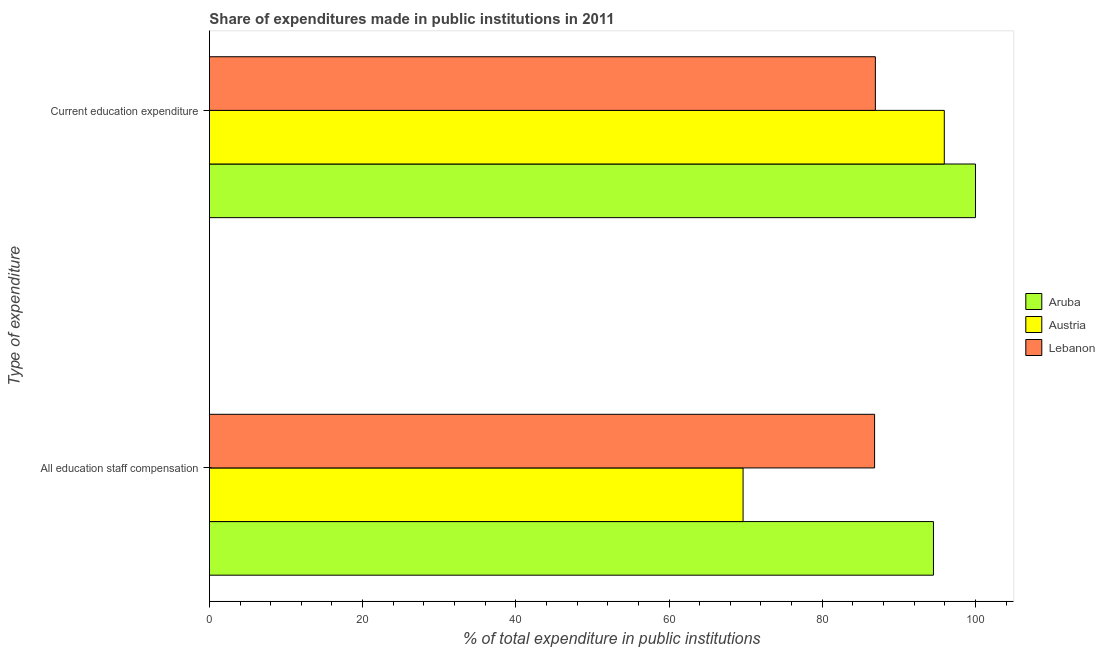How many groups of bars are there?
Provide a succinct answer. 2. Are the number of bars on each tick of the Y-axis equal?
Your answer should be very brief. Yes. How many bars are there on the 1st tick from the bottom?
Offer a terse response. 3. What is the label of the 1st group of bars from the top?
Offer a terse response. Current education expenditure. What is the expenditure in staff compensation in Austria?
Your answer should be very brief. 69.66. Across all countries, what is the maximum expenditure in staff compensation?
Your answer should be compact. 94.51. Across all countries, what is the minimum expenditure in staff compensation?
Offer a very short reply. 69.66. In which country was the expenditure in staff compensation maximum?
Your answer should be very brief. Aruba. In which country was the expenditure in staff compensation minimum?
Give a very brief answer. Austria. What is the total expenditure in education in the graph?
Ensure brevity in your answer.  282.86. What is the difference between the expenditure in staff compensation in Aruba and that in Austria?
Your answer should be very brief. 24.85. What is the difference between the expenditure in staff compensation in Aruba and the expenditure in education in Lebanon?
Keep it short and to the point. 7.58. What is the average expenditure in staff compensation per country?
Make the answer very short. 83.67. What is the difference between the expenditure in education and expenditure in staff compensation in Aruba?
Offer a very short reply. 5.49. What is the ratio of the expenditure in education in Lebanon to that in Aruba?
Ensure brevity in your answer.  0.87. Is the expenditure in staff compensation in Lebanon less than that in Aruba?
Provide a succinct answer. Yes. In how many countries, is the expenditure in education greater than the average expenditure in education taken over all countries?
Your answer should be very brief. 2. What does the 3rd bar from the top in All education staff compensation represents?
Offer a terse response. Aruba. Are all the bars in the graph horizontal?
Give a very brief answer. Yes. Are the values on the major ticks of X-axis written in scientific E-notation?
Give a very brief answer. No. Does the graph contain any zero values?
Offer a very short reply. No. Does the graph contain grids?
Your response must be concise. No. Where does the legend appear in the graph?
Your answer should be compact. Center right. How many legend labels are there?
Keep it short and to the point. 3. How are the legend labels stacked?
Your answer should be very brief. Vertical. What is the title of the graph?
Provide a short and direct response. Share of expenditures made in public institutions in 2011. What is the label or title of the X-axis?
Make the answer very short. % of total expenditure in public institutions. What is the label or title of the Y-axis?
Offer a very short reply. Type of expenditure. What is the % of total expenditure in public institutions in Aruba in All education staff compensation?
Keep it short and to the point. 94.51. What is the % of total expenditure in public institutions in Austria in All education staff compensation?
Provide a short and direct response. 69.66. What is the % of total expenditure in public institutions of Lebanon in All education staff compensation?
Ensure brevity in your answer.  86.83. What is the % of total expenditure in public institutions of Austria in Current education expenditure?
Make the answer very short. 95.93. What is the % of total expenditure in public institutions in Lebanon in Current education expenditure?
Provide a short and direct response. 86.93. Across all Type of expenditure, what is the maximum % of total expenditure in public institutions in Austria?
Offer a very short reply. 95.93. Across all Type of expenditure, what is the maximum % of total expenditure in public institutions in Lebanon?
Offer a very short reply. 86.93. Across all Type of expenditure, what is the minimum % of total expenditure in public institutions of Aruba?
Provide a short and direct response. 94.51. Across all Type of expenditure, what is the minimum % of total expenditure in public institutions of Austria?
Keep it short and to the point. 69.66. Across all Type of expenditure, what is the minimum % of total expenditure in public institutions in Lebanon?
Make the answer very short. 86.83. What is the total % of total expenditure in public institutions of Aruba in the graph?
Your answer should be compact. 194.51. What is the total % of total expenditure in public institutions in Austria in the graph?
Provide a short and direct response. 165.59. What is the total % of total expenditure in public institutions in Lebanon in the graph?
Offer a terse response. 173.76. What is the difference between the % of total expenditure in public institutions of Aruba in All education staff compensation and that in Current education expenditure?
Your answer should be compact. -5.49. What is the difference between the % of total expenditure in public institutions in Austria in All education staff compensation and that in Current education expenditure?
Provide a succinct answer. -26.27. What is the difference between the % of total expenditure in public institutions in Lebanon in All education staff compensation and that in Current education expenditure?
Give a very brief answer. -0.1. What is the difference between the % of total expenditure in public institutions in Aruba in All education staff compensation and the % of total expenditure in public institutions in Austria in Current education expenditure?
Give a very brief answer. -1.42. What is the difference between the % of total expenditure in public institutions of Aruba in All education staff compensation and the % of total expenditure in public institutions of Lebanon in Current education expenditure?
Offer a very short reply. 7.58. What is the difference between the % of total expenditure in public institutions in Austria in All education staff compensation and the % of total expenditure in public institutions in Lebanon in Current education expenditure?
Provide a short and direct response. -17.27. What is the average % of total expenditure in public institutions of Aruba per Type of expenditure?
Your response must be concise. 97.26. What is the average % of total expenditure in public institutions in Austria per Type of expenditure?
Keep it short and to the point. 82.8. What is the average % of total expenditure in public institutions of Lebanon per Type of expenditure?
Offer a very short reply. 86.88. What is the difference between the % of total expenditure in public institutions of Aruba and % of total expenditure in public institutions of Austria in All education staff compensation?
Provide a short and direct response. 24.85. What is the difference between the % of total expenditure in public institutions in Aruba and % of total expenditure in public institutions in Lebanon in All education staff compensation?
Your response must be concise. 7.68. What is the difference between the % of total expenditure in public institutions of Austria and % of total expenditure in public institutions of Lebanon in All education staff compensation?
Make the answer very short. -17.17. What is the difference between the % of total expenditure in public institutions of Aruba and % of total expenditure in public institutions of Austria in Current education expenditure?
Give a very brief answer. 4.07. What is the difference between the % of total expenditure in public institutions of Aruba and % of total expenditure in public institutions of Lebanon in Current education expenditure?
Ensure brevity in your answer.  13.07. What is the difference between the % of total expenditure in public institutions in Austria and % of total expenditure in public institutions in Lebanon in Current education expenditure?
Ensure brevity in your answer.  9. What is the ratio of the % of total expenditure in public institutions in Aruba in All education staff compensation to that in Current education expenditure?
Provide a short and direct response. 0.95. What is the ratio of the % of total expenditure in public institutions of Austria in All education staff compensation to that in Current education expenditure?
Your response must be concise. 0.73. What is the ratio of the % of total expenditure in public institutions of Lebanon in All education staff compensation to that in Current education expenditure?
Provide a short and direct response. 1. What is the difference between the highest and the second highest % of total expenditure in public institutions in Aruba?
Offer a very short reply. 5.49. What is the difference between the highest and the second highest % of total expenditure in public institutions in Austria?
Provide a succinct answer. 26.27. What is the difference between the highest and the second highest % of total expenditure in public institutions of Lebanon?
Your answer should be very brief. 0.1. What is the difference between the highest and the lowest % of total expenditure in public institutions of Aruba?
Offer a terse response. 5.49. What is the difference between the highest and the lowest % of total expenditure in public institutions of Austria?
Provide a short and direct response. 26.27. What is the difference between the highest and the lowest % of total expenditure in public institutions of Lebanon?
Give a very brief answer. 0.1. 